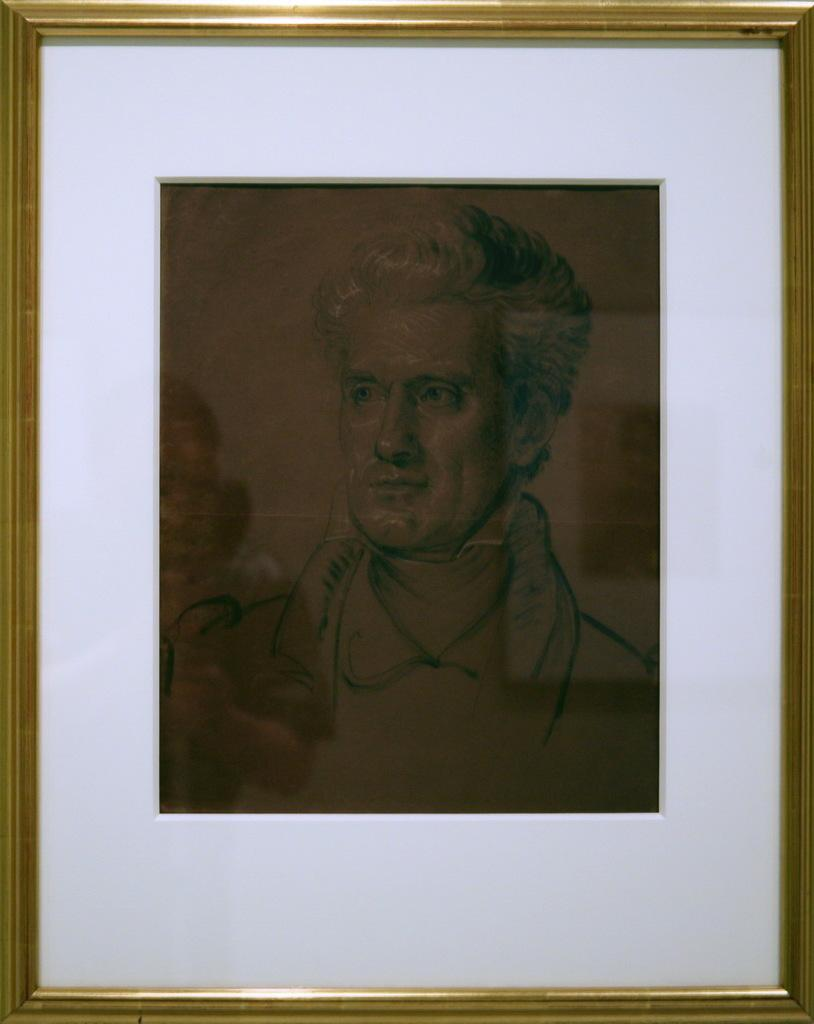What object is present in the image that typically holds a photograph? There is a photo frame in the image. What is the man in the photo doing? The man is looking to the left side in the photo. What is the color of the photo frame? The frame of the photo is in gold color. Are there any plastic flowers visible in the image? There is no mention of plastic flowers in the provided facts, so we cannot determine their presence in the image. 